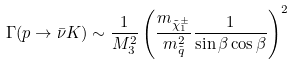<formula> <loc_0><loc_0><loc_500><loc_500>\Gamma ( p \rightarrow \bar { \nu } K ) \sim \frac { 1 } { M _ { 3 } ^ { 2 } } \left ( \frac { m _ { \tilde { \chi } _ { 1 } ^ { \pm } } } { m _ { \tilde { q } } ^ { 2 } } \frac { 1 } { \sin { \beta } \cos { \beta } } \right ) ^ { 2 }</formula> 